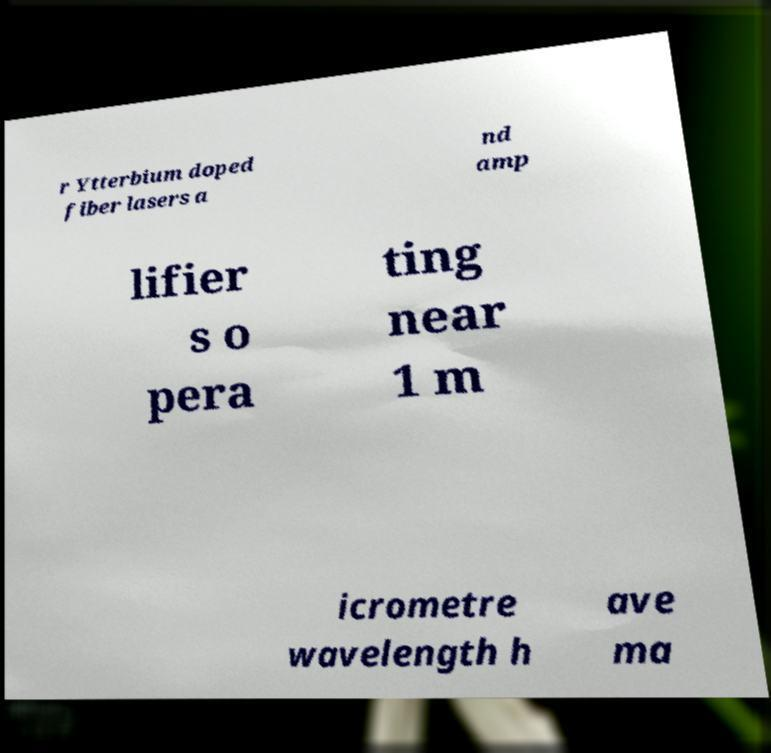Could you assist in decoding the text presented in this image and type it out clearly? r Ytterbium doped fiber lasers a nd amp lifier s o pera ting near 1 m icrometre wavelength h ave ma 